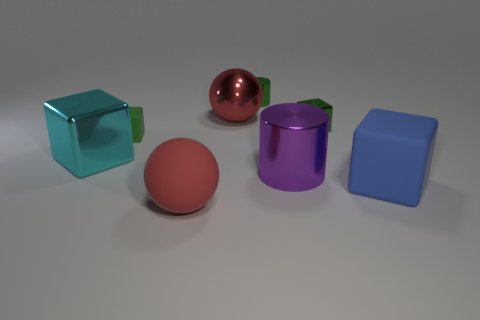The matte object that is both behind the red rubber ball and on the left side of the big matte block has what shape?
Give a very brief answer. Cube. Are there the same number of tiny rubber blocks that are to the right of the large purple thing and large red spheres that are behind the blue rubber block?
Keep it short and to the point. No. There is a small matte object that is to the left of the purple object; is its shape the same as the red matte thing?
Offer a terse response. No. What number of red things are either blocks or matte things?
Provide a succinct answer. 1. What material is the other large object that is the same shape as the large blue thing?
Make the answer very short. Metal. What shape is the red object that is behind the green rubber cube?
Make the answer very short. Sphere. Are there any tiny cyan objects that have the same material as the large cyan thing?
Your answer should be compact. No. Is the size of the cyan cube the same as the blue cube?
Your answer should be compact. Yes. How many blocks are either red objects or large blue matte objects?
Ensure brevity in your answer.  1. There is another cube that is the same color as the small metal block; what is it made of?
Your answer should be compact. Rubber. 